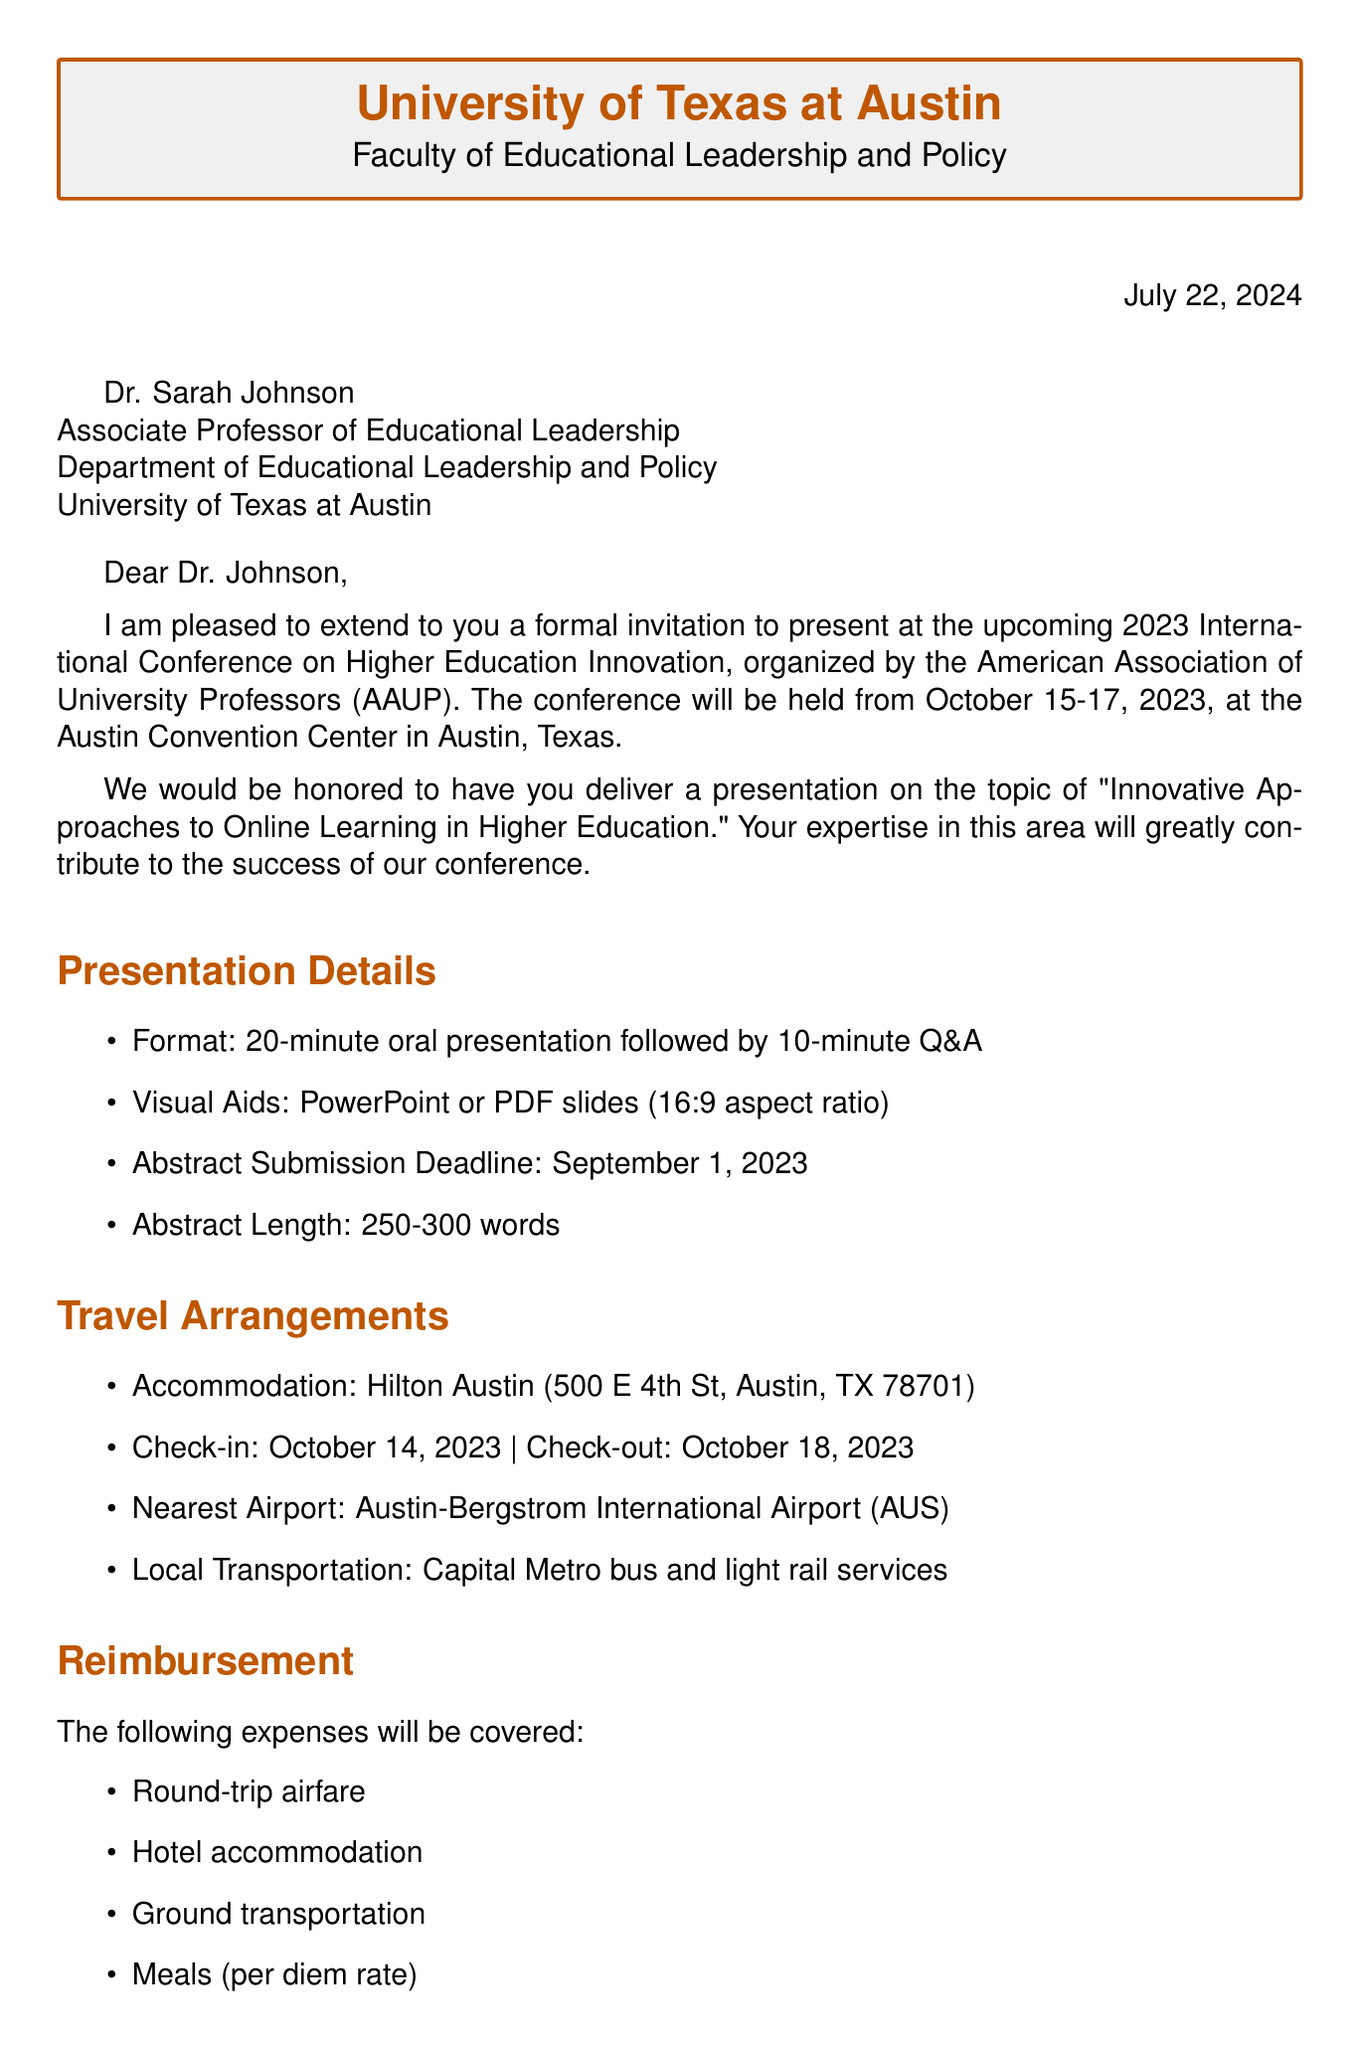What is the name of the conference? The document specifies the name of the conference as "2023 International Conference on Higher Education Innovation."
Answer: 2023 International Conference on Higher Education Innovation Who is the recipient of the invitation? The invitation is addressed to Dr. Sarah Johnson.
Answer: Dr. Sarah Johnson What is the presentation submission deadline? The document states that the abstract submission deadline is September 1, 2023.
Answer: September 1, 2023 How long is the oral presentation? The presentation guidelines indicate that the oral presentation should last for 20 minutes.
Answer: 20 minutes What hotel is recommended for accommodation? The document recommends staying at the Hilton Austin for accommodation.
Answer: Hilton Austin What expenses will be covered for reimbursement? The document lists round-trip airfare, hotel accommodation, ground transportation, and meals (per diem rate) as covered expenses.
Answer: Round-trip airfare, hotel accommodation, ground transportation, meals Which airport is nearest to the conference location? The nearest airport mentioned in the document is Austin-Bergstrom International Airport.
Answer: Austin-Bergstrom International Airport What is the registration fee status for invited speakers? The document states that the registration fee is waived for invited speakers.
Answer: Waived Who should be contacted for further information? The document indicates that Dr. Michael Chang is the contact person for further information.
Answer: Dr. Michael Chang 